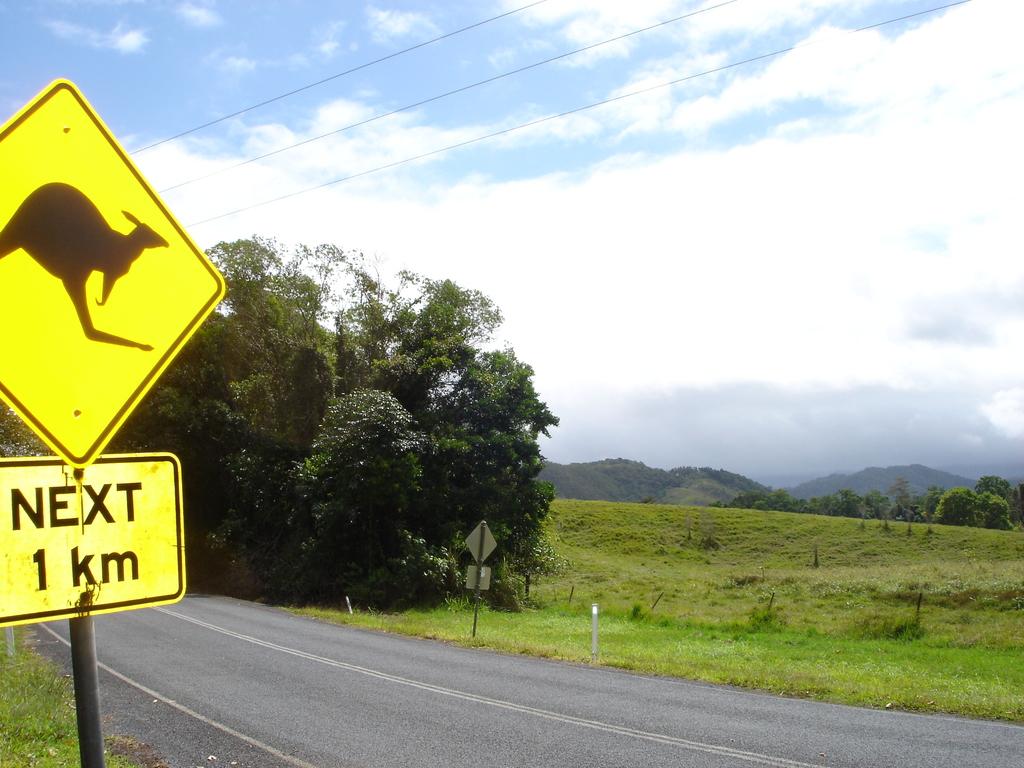What is the word below the kangaroo?
Your response must be concise. Next. 